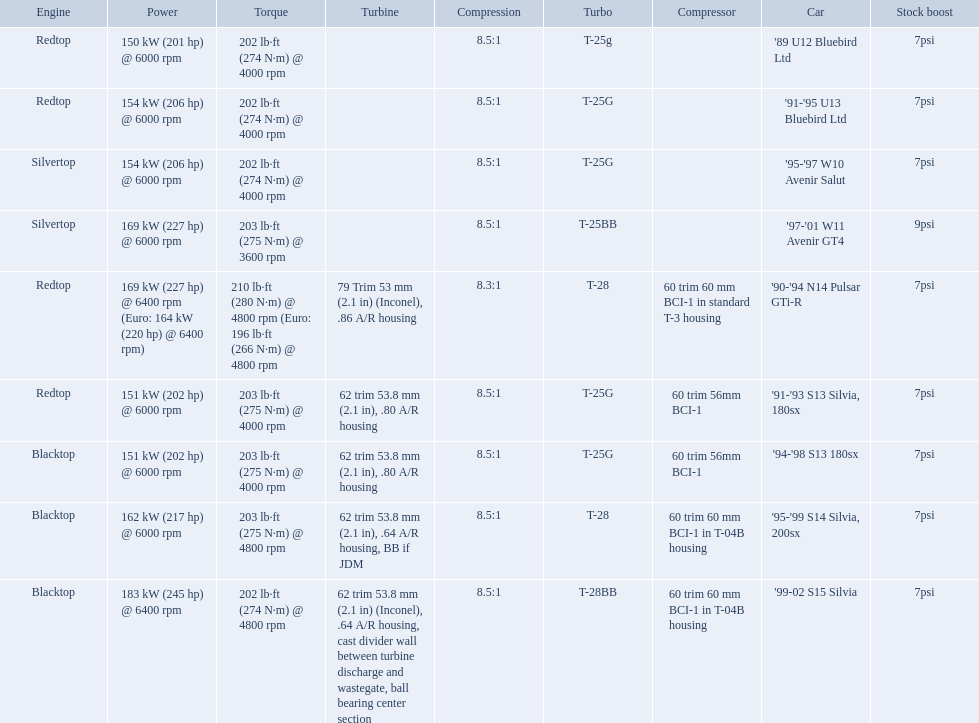What are all of the nissan cars? '89 U12 Bluebird Ltd, '91-'95 U13 Bluebird Ltd, '95-'97 W10 Avenir Salut, '97-'01 W11 Avenir GT4, '90-'94 N14 Pulsar GTi-R, '91-'93 S13 Silvia, 180sx, '94-'98 S13 180sx, '95-'99 S14 Silvia, 200sx, '99-02 S15 Silvia. Of these cars, which one is a '90-'94 n14 pulsar gti-r? '90-'94 N14 Pulsar GTi-R. What is the compression of this car? 8.3:1. What are all of the cars? '89 U12 Bluebird Ltd, '91-'95 U13 Bluebird Ltd, '95-'97 W10 Avenir Salut, '97-'01 W11 Avenir GT4, '90-'94 N14 Pulsar GTi-R, '91-'93 S13 Silvia, 180sx, '94-'98 S13 180sx, '95-'99 S14 Silvia, 200sx, '99-02 S15 Silvia. What is their rated power? 150 kW (201 hp) @ 6000 rpm, 154 kW (206 hp) @ 6000 rpm, 154 kW (206 hp) @ 6000 rpm, 169 kW (227 hp) @ 6000 rpm, 169 kW (227 hp) @ 6400 rpm (Euro: 164 kW (220 hp) @ 6400 rpm), 151 kW (202 hp) @ 6000 rpm, 151 kW (202 hp) @ 6000 rpm, 162 kW (217 hp) @ 6000 rpm, 183 kW (245 hp) @ 6400 rpm. Which car has the most power? '99-02 S15 Silvia. 